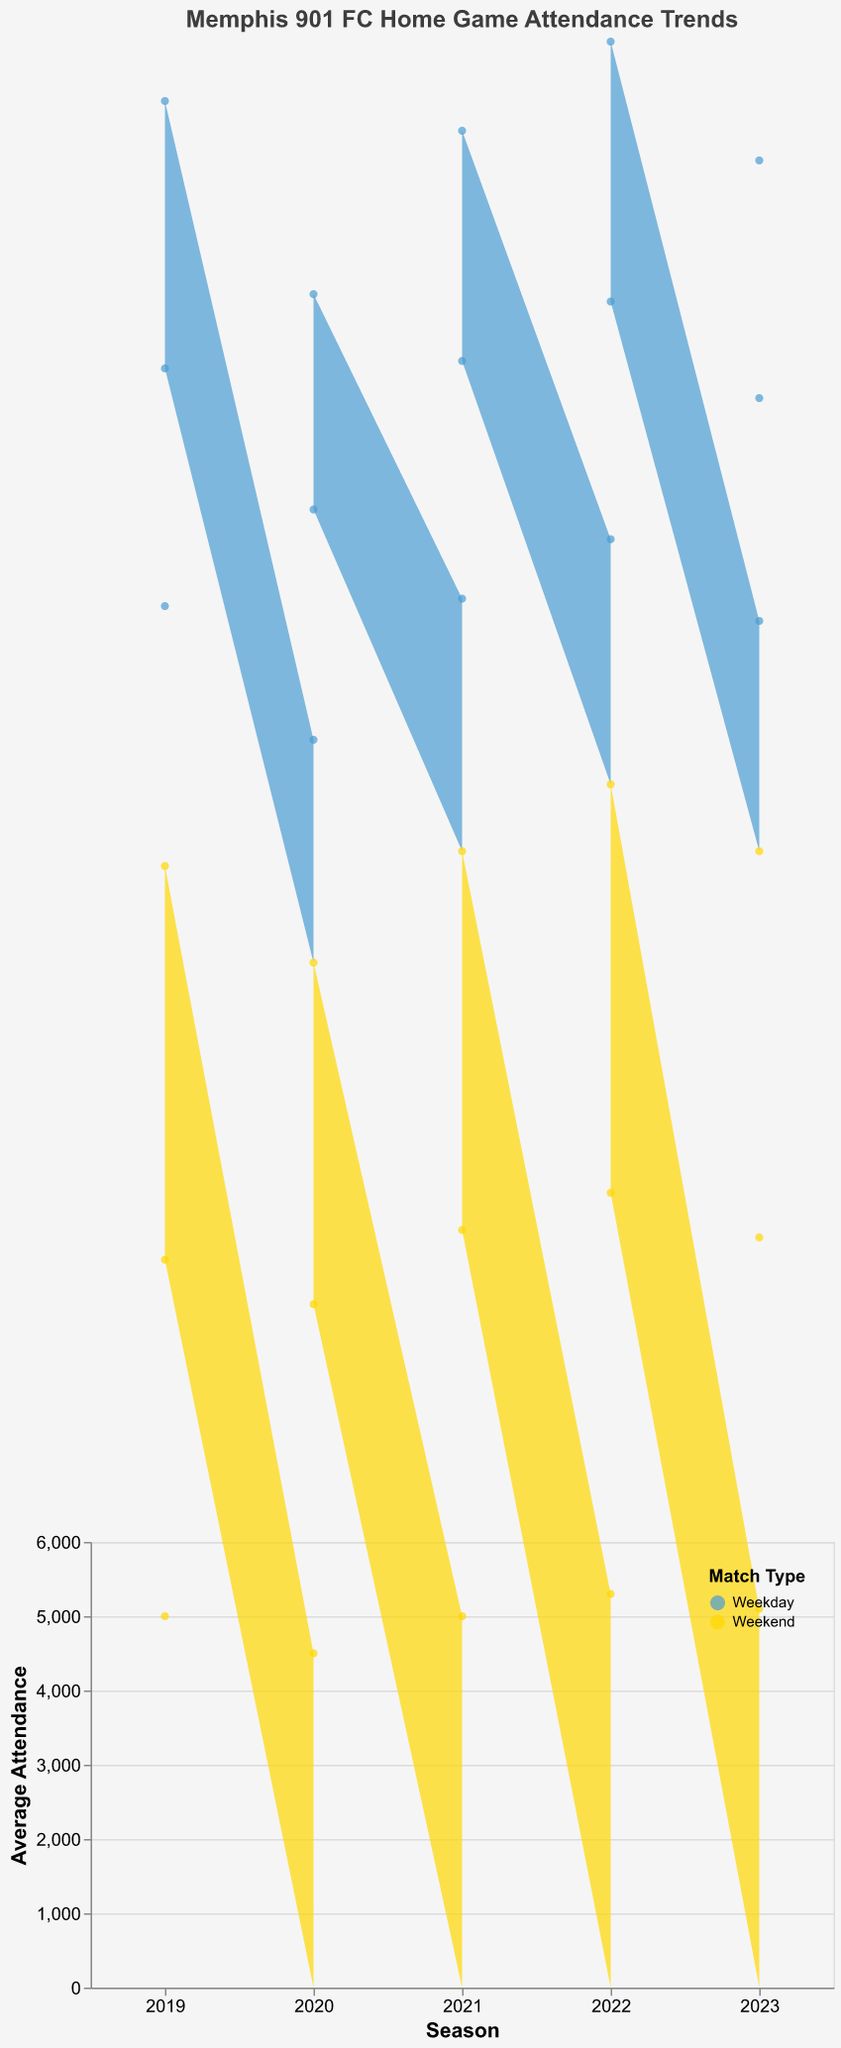What is the title of the chart? The title of the chart is at the top and it reads "Memphis 901 FC Home Game Attendance Trends."
Answer: Memphis 901 FC Home Game Attendance Trends What are the colors used to represent Weekday and Weekend matches? The color legend indicates that Weekday matches are shown in a blue shade while Weekend matches are depicted in a yellow shade.
Answer: Blue and Yellow How many seasons are depicted in the chart? The x-axis labels show each distinct season from 2019 to 2023. Counting these labels gives the total number of seasons shown.
Answer: 5 Which season had the highest average weekend match attendance? By checking the peaks in the yellow areas of the chart, the highest peak corresponds to the 2022 season with weekend attendances of 5300, 5400, and 5500.
Answer: 2022 How does the average attendance of weekday matches in 2019 compare to that in 2020? In 2019, weekday attendances are 3500, 3200, and 3600 which average to 3433.33. In 2020, the attendances are 3000, 3100, and 2900 which average to 3000.
Answer: Higher in 2019 What’s the difference in average attendance between weekday and weekend matches in the 2021 season? Average weekday attendance in 2021 is (3400 + 3200 + 3100)/3 = 3233.33. Average weekend attendance in 2021 is (5000 + 5200 + 5100)/3 = 5100. The difference is 5100 - 3233.33 = 1866.67.
Answer: 1866.67 In which year did the average weekday attendance see an increase compared to the previous year? We need to check the average weekday attendance of each year. Only 2022 saw an increase compared to its previous year, 2021. 2023 decreased again after 2022.
Answer: 2022 Which match type generally had higher attendance over the shown seasons? From the chart, the yellow (weekend) area is consistently higher than the blue (weekday) area across the seasons.
Answer: Weekend matches What is the trend observed in weekend match attendance from 2019 to 2023? Observing the yellow areas, the weekend attendance shows an overall increase from 2019 to 2022, but a slight decrease from 2022 to 2023.
Answer: Increasing then slightly decreasing 